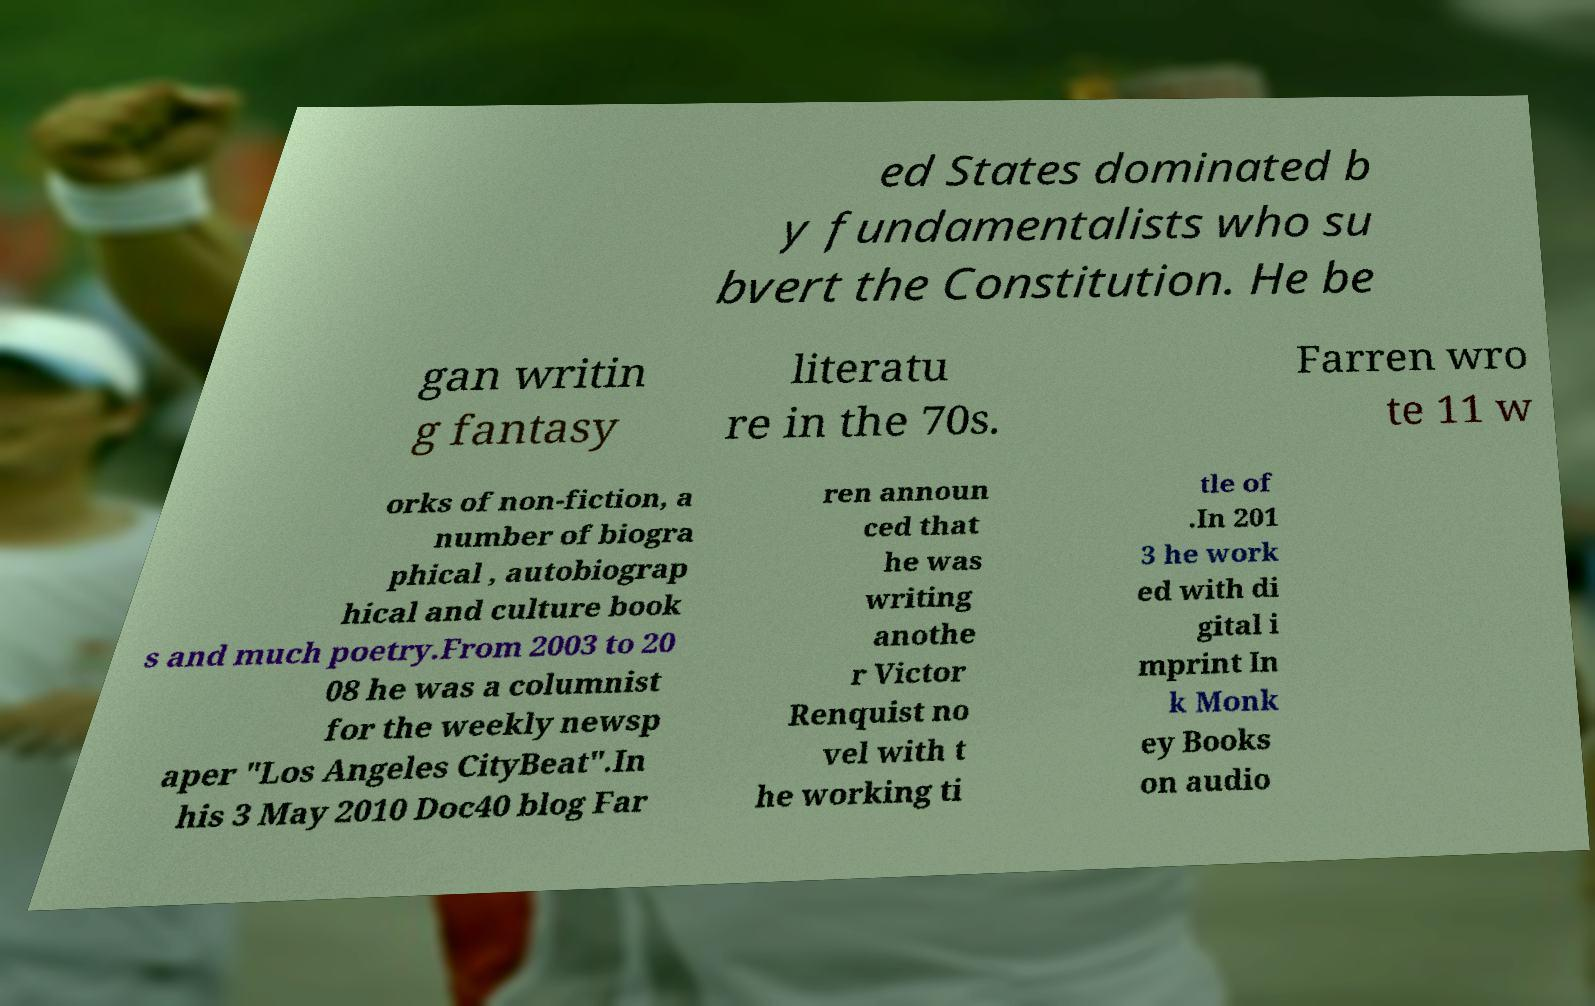Can you read and provide the text displayed in the image?This photo seems to have some interesting text. Can you extract and type it out for me? ed States dominated b y fundamentalists who su bvert the Constitution. He be gan writin g fantasy literatu re in the 70s. Farren wro te 11 w orks of non-fiction, a number of biogra phical , autobiograp hical and culture book s and much poetry.From 2003 to 20 08 he was a columnist for the weekly newsp aper "Los Angeles CityBeat".In his 3 May 2010 Doc40 blog Far ren announ ced that he was writing anothe r Victor Renquist no vel with t he working ti tle of .In 201 3 he work ed with di gital i mprint In k Monk ey Books on audio 